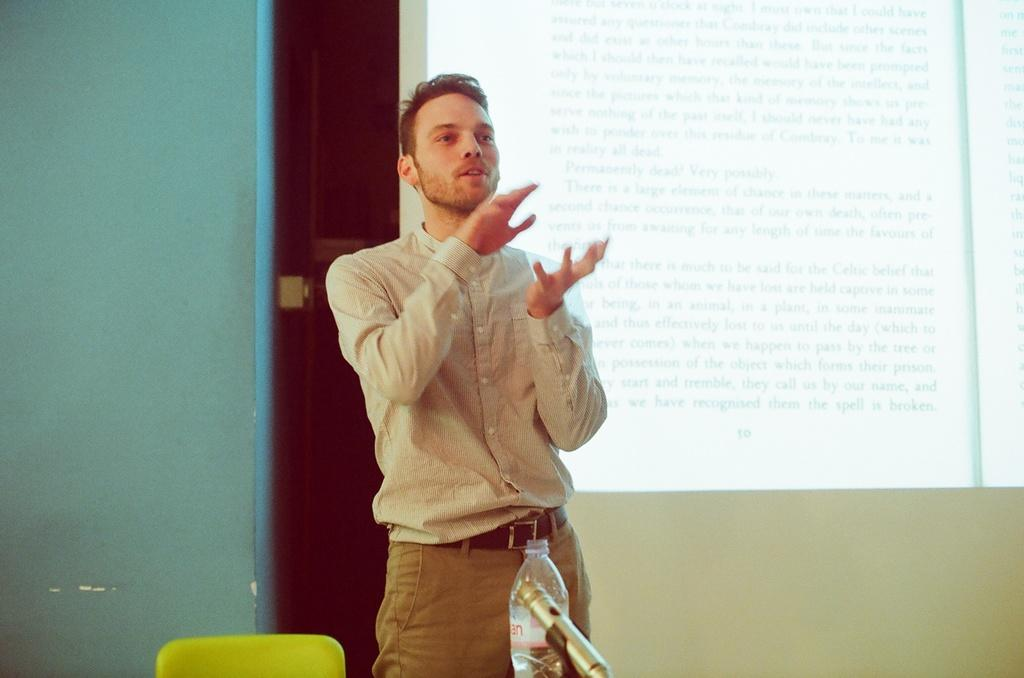What is the main subject of the image? There is a man standing in the image. What object is present in the image that the man might use for sitting? There is a chair in the image. What object in the image might the man be using for drinking? There is a bottle in the image. What object in the image might the man be using for speaking? There is a mic in the image. What can be seen in the background of the image? There is a screen and a wall in the background of the image. Can you tell me how many dogs are present in the image? There are no dogs present in the image. What type of bell can be seen hanging from the wall in the image? There is no bell present in the image; only a screen and a wall are visible in the background. 